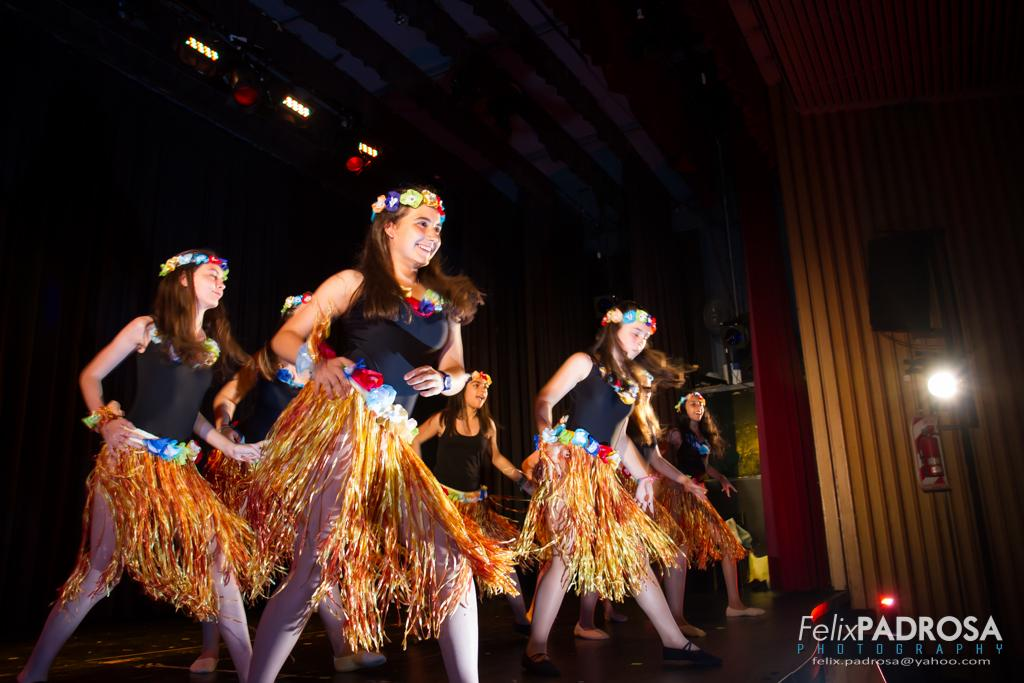Who is present in the image? There are girls in the image. What are the girls doing in the image? The girls are dancing. What can be seen at the top of the image? There are lights visible at the top of the image. What type of shoes are the girls wearing while dancing in the image? There is no information about the girls' shoes in the image, so we cannot determine what type of shoes they are wearing. 